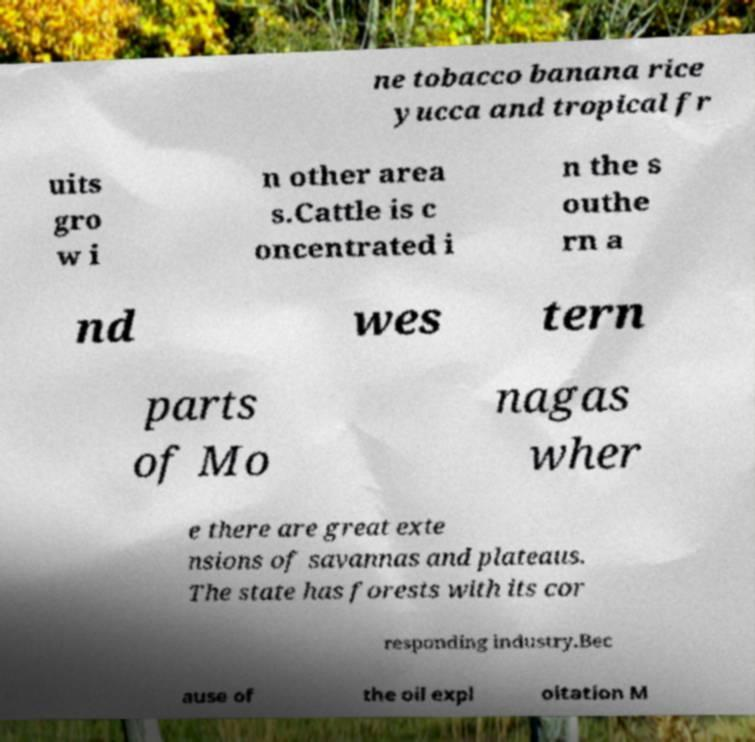There's text embedded in this image that I need extracted. Can you transcribe it verbatim? ne tobacco banana rice yucca and tropical fr uits gro w i n other area s.Cattle is c oncentrated i n the s outhe rn a nd wes tern parts of Mo nagas wher e there are great exte nsions of savannas and plateaus. The state has forests with its cor responding industry.Bec ause of the oil expl oitation M 